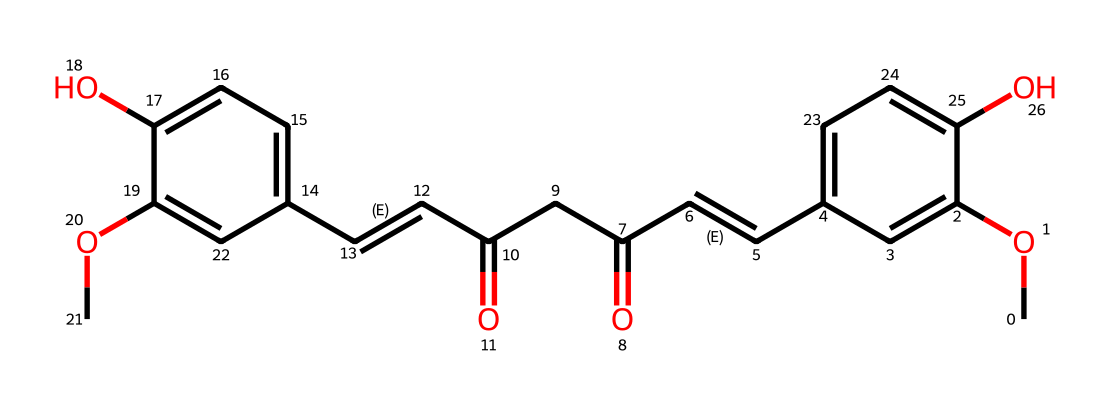What is the primary color associated with curcumin? The visual structure of curcumin shows a bright yellow chemical composition, which is responsible for its use as a natural dye.
Answer: yellow How many oxygen atoms are present in curcumin? By examining the SMILES representation, we count four distinct oxygen atoms within the structure.
Answer: four What type of chemical compound is curcumin classified as? Curcumin, based on its structure with multiple aromatic rings and functional groups (like hydroxyl and carbonyl), is classified as a polyphenolic compound.
Answer: polyphenol What is the number of double bonds in the structure of curcumin? Looking at the SMILES, we identify two double bonds indicated by the "/C=C/" notation, leading us to conclude that there are two double bonds.
Answer: two How many rings are part of curcumin's structure? Analyzing the total number of cyclic structures present, we find that curcumin contains two distinct aromatic rings.
Answer: two What functional groups can be identified in curcumin? By inspecting the chemical structure, we find hydroxyl groups (-OH) and carbonyl groups (C=O), which are common functional groups in organic compounds.
Answer: hydroxyl and carbonyl Does curcumin contain any methoxy groups? The presence of "OC" in the SMILES indicates the existence of methoxy groups in the structure.
Answer: yes 